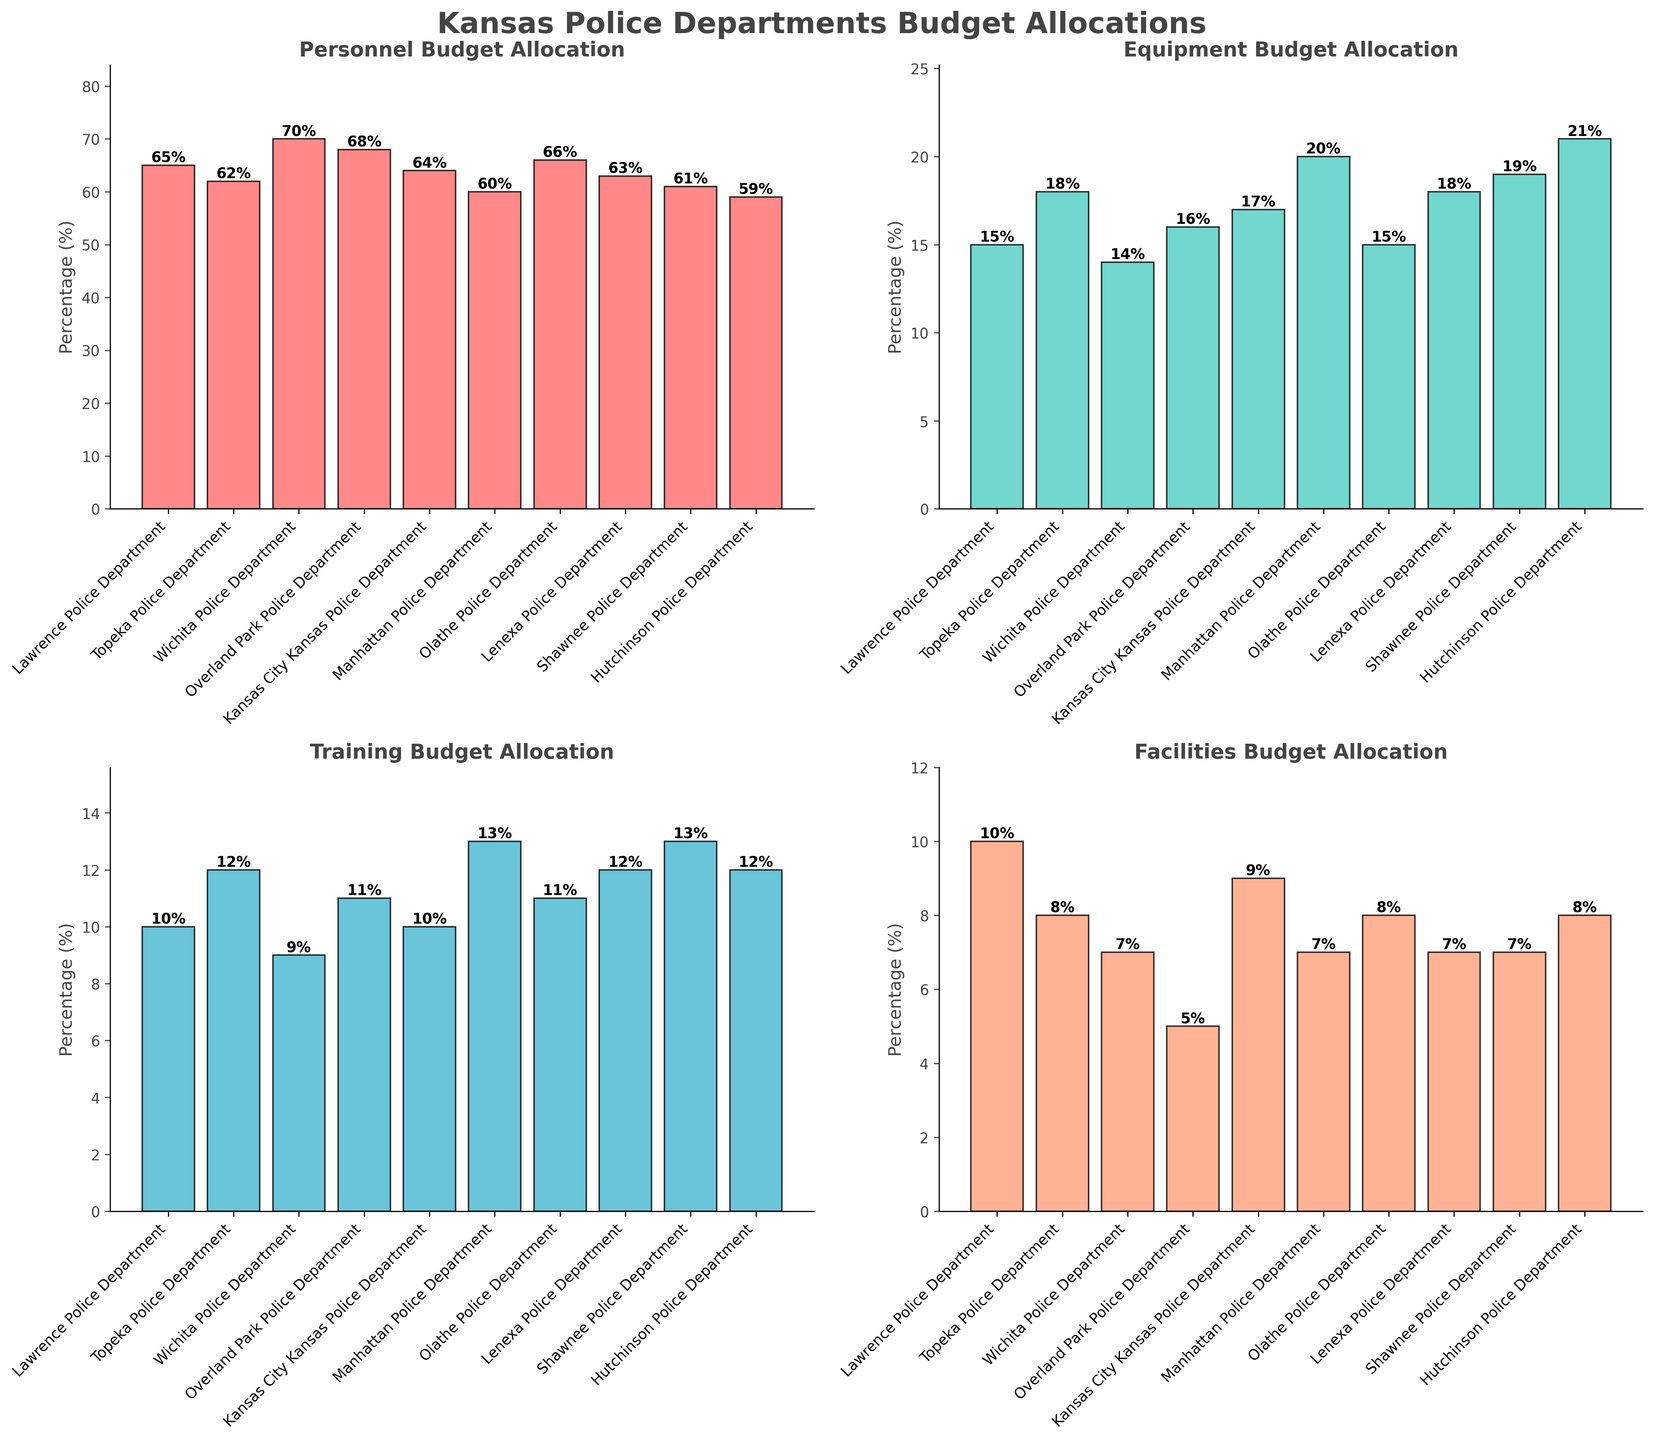Which department allocated the highest percentage to Personnel? Looking at the bar heights in the Personnel Budget Allocation subplot, the Wichita Police Department's bar is the tallest.
Answer: Wichita Police Department Which two departments have the same percentage allocation for Training? Comparing the bar heights in the Training Budget Allocation subplot, both Lawrence Police Department and Kansas City Kansas Police Department have bars of the same height with 10%.
Answer: Lawrence Police Department and Kansas City Kansas Police Department What is the total percentage allocation for the Facilities category for Lawrence, Topeka, and Wichita Police Departments? Summing up the percentage from the Facilities Budget Allocation subplot: Lawrence (10%), Topeka (8%), Wichita (7%) gives 10 + 8 + 7 = 25%.
Answer: 25% Which department has the lowest percentage allocation for Equipment? From the Equipment Budget Allocation subplot, Wichita Police Department's bar is the lowest at 14%.
Answer: Wichita Police Department How much more percentage does the Manhattan Police Department allocate to Training compared to Facilities? From the subplots, Manhattan Police Department allocates 13% to Training and 7% to Facilities. The difference is 13 - 7 = 6%.
Answer: 6% Which department has a higher allocation to Personnel: Lawrence or Olathe? Comparing the Personnel Budget Allocation subplot, Olathe Police Department (66%) has a higher allocation than Lawrence Police Department (65%).
Answer: Olathe Police Department What is the average percentage allocation for Equipment across all departments? Sum the percentages for Equipment: 15 + 18 + 14 + 16 + 17 + 20 + 15 + 18 + 19 + 21 = 173. The average is 173 / 10 = 17.3%.
Answer: 17.3% Is the allocation for Training higher or lower than Facilities for Shawnee Police Department? In the subplots, Shawnee Police Department allocates 13% to Training and 7% to Facilities. Training allocation (13%) is higher than Facilities (7%).
Answer: Higher Which category has the most uniform allocation across the departments? Assessing the variation in bar heights across all subplots, the Personnel category bars seem closest in height, indicating a more uniform allocation across departments.
Answer: Personnel Who allocates a higher percentage to Equipment, Lenexa or Lawrence Police Department? From the Equipment Budget Allocation subplot, Lenexa Police Department (18%) allocates more than Lawrence Police Department (15%).
Answer: Lenexa Police Department 